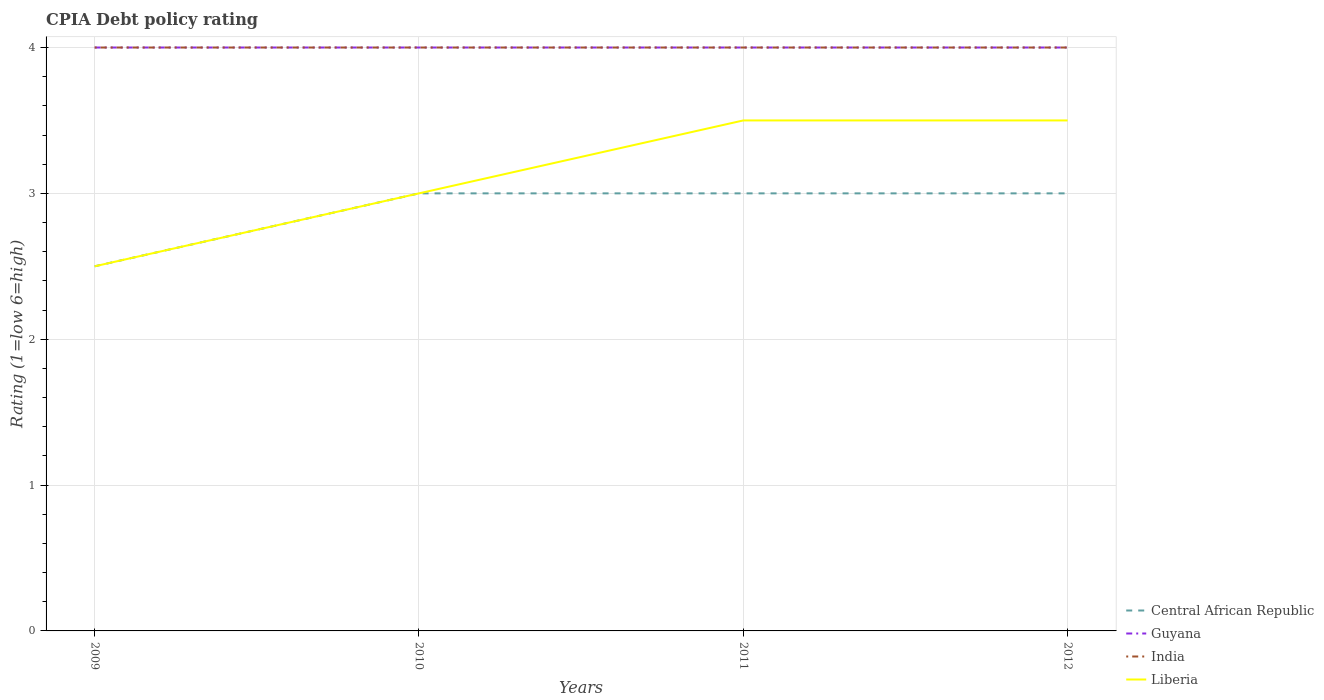How many different coloured lines are there?
Keep it short and to the point. 4. What is the total CPIA rating in India in the graph?
Your answer should be very brief. 0. What is the difference between the highest and the lowest CPIA rating in India?
Ensure brevity in your answer.  0. Is the CPIA rating in Guyana strictly greater than the CPIA rating in Central African Republic over the years?
Keep it short and to the point. No. Are the values on the major ticks of Y-axis written in scientific E-notation?
Keep it short and to the point. No. Does the graph contain any zero values?
Offer a terse response. No. Where does the legend appear in the graph?
Give a very brief answer. Bottom right. What is the title of the graph?
Offer a terse response. CPIA Debt policy rating. What is the label or title of the Y-axis?
Provide a succinct answer. Rating (1=low 6=high). What is the Rating (1=low 6=high) in India in 2009?
Offer a very short reply. 4. What is the Rating (1=low 6=high) of Liberia in 2009?
Offer a terse response. 2.5. What is the Rating (1=low 6=high) in Liberia in 2010?
Your answer should be very brief. 3. What is the Rating (1=low 6=high) of Central African Republic in 2011?
Your answer should be compact. 3. What is the Rating (1=low 6=high) in India in 2011?
Provide a short and direct response. 4. What is the Rating (1=low 6=high) in Central African Republic in 2012?
Provide a succinct answer. 3. What is the Rating (1=low 6=high) of Guyana in 2012?
Provide a succinct answer. 4. What is the Rating (1=low 6=high) in India in 2012?
Make the answer very short. 4. Across all years, what is the maximum Rating (1=low 6=high) in Central African Republic?
Provide a succinct answer. 3. Across all years, what is the minimum Rating (1=low 6=high) of Guyana?
Give a very brief answer. 4. Across all years, what is the minimum Rating (1=low 6=high) in India?
Your answer should be compact. 4. Across all years, what is the minimum Rating (1=low 6=high) in Liberia?
Provide a succinct answer. 2.5. What is the difference between the Rating (1=low 6=high) of Central African Republic in 2009 and that in 2010?
Offer a terse response. -0.5. What is the difference between the Rating (1=low 6=high) in Liberia in 2009 and that in 2010?
Keep it short and to the point. -0.5. What is the difference between the Rating (1=low 6=high) in India in 2009 and that in 2011?
Make the answer very short. 0. What is the difference between the Rating (1=low 6=high) in Liberia in 2009 and that in 2011?
Give a very brief answer. -1. What is the difference between the Rating (1=low 6=high) of India in 2009 and that in 2012?
Offer a very short reply. 0. What is the difference between the Rating (1=low 6=high) of India in 2010 and that in 2011?
Keep it short and to the point. 0. What is the difference between the Rating (1=low 6=high) in India in 2010 and that in 2012?
Provide a short and direct response. 0. What is the difference between the Rating (1=low 6=high) in Guyana in 2011 and that in 2012?
Provide a succinct answer. 0. What is the difference between the Rating (1=low 6=high) of Liberia in 2011 and that in 2012?
Keep it short and to the point. 0. What is the difference between the Rating (1=low 6=high) in Central African Republic in 2009 and the Rating (1=low 6=high) in Guyana in 2010?
Keep it short and to the point. -1.5. What is the difference between the Rating (1=low 6=high) of Central African Republic in 2009 and the Rating (1=low 6=high) of Liberia in 2010?
Your answer should be compact. -0.5. What is the difference between the Rating (1=low 6=high) in Guyana in 2009 and the Rating (1=low 6=high) in India in 2010?
Ensure brevity in your answer.  0. What is the difference between the Rating (1=low 6=high) of Central African Republic in 2009 and the Rating (1=low 6=high) of Guyana in 2011?
Give a very brief answer. -1.5. What is the difference between the Rating (1=low 6=high) in Guyana in 2009 and the Rating (1=low 6=high) in India in 2011?
Your response must be concise. 0. What is the difference between the Rating (1=low 6=high) of Central African Republic in 2009 and the Rating (1=low 6=high) of Guyana in 2012?
Provide a short and direct response. -1.5. What is the difference between the Rating (1=low 6=high) in Central African Republic in 2009 and the Rating (1=low 6=high) in Liberia in 2012?
Provide a succinct answer. -1. What is the difference between the Rating (1=low 6=high) in India in 2009 and the Rating (1=low 6=high) in Liberia in 2012?
Ensure brevity in your answer.  0.5. What is the difference between the Rating (1=low 6=high) in Central African Republic in 2010 and the Rating (1=low 6=high) in India in 2011?
Offer a very short reply. -1. What is the difference between the Rating (1=low 6=high) of Central African Republic in 2010 and the Rating (1=low 6=high) of Liberia in 2011?
Your answer should be compact. -0.5. What is the difference between the Rating (1=low 6=high) in Guyana in 2010 and the Rating (1=low 6=high) in India in 2011?
Your answer should be very brief. 0. What is the difference between the Rating (1=low 6=high) in India in 2010 and the Rating (1=low 6=high) in Liberia in 2011?
Keep it short and to the point. 0.5. What is the difference between the Rating (1=low 6=high) in Central African Republic in 2010 and the Rating (1=low 6=high) in Guyana in 2012?
Your answer should be compact. -1. What is the difference between the Rating (1=low 6=high) in Central African Republic in 2010 and the Rating (1=low 6=high) in India in 2012?
Offer a very short reply. -1. What is the difference between the Rating (1=low 6=high) of Guyana in 2010 and the Rating (1=low 6=high) of India in 2012?
Ensure brevity in your answer.  0. What is the difference between the Rating (1=low 6=high) of India in 2010 and the Rating (1=low 6=high) of Liberia in 2012?
Your answer should be compact. 0.5. What is the difference between the Rating (1=low 6=high) of Central African Republic in 2011 and the Rating (1=low 6=high) of Guyana in 2012?
Your response must be concise. -1. What is the difference between the Rating (1=low 6=high) in Central African Republic in 2011 and the Rating (1=low 6=high) in Liberia in 2012?
Your response must be concise. -0.5. What is the difference between the Rating (1=low 6=high) of Guyana in 2011 and the Rating (1=low 6=high) of India in 2012?
Offer a terse response. 0. What is the difference between the Rating (1=low 6=high) in Guyana in 2011 and the Rating (1=low 6=high) in Liberia in 2012?
Keep it short and to the point. 0.5. What is the difference between the Rating (1=low 6=high) of India in 2011 and the Rating (1=low 6=high) of Liberia in 2012?
Give a very brief answer. 0.5. What is the average Rating (1=low 6=high) of Central African Republic per year?
Your answer should be compact. 2.88. What is the average Rating (1=low 6=high) in Guyana per year?
Provide a short and direct response. 4. What is the average Rating (1=low 6=high) of India per year?
Your answer should be compact. 4. What is the average Rating (1=low 6=high) of Liberia per year?
Your answer should be compact. 3.12. In the year 2009, what is the difference between the Rating (1=low 6=high) of Central African Republic and Rating (1=low 6=high) of India?
Provide a succinct answer. -1.5. In the year 2009, what is the difference between the Rating (1=low 6=high) of Central African Republic and Rating (1=low 6=high) of Liberia?
Give a very brief answer. 0. In the year 2009, what is the difference between the Rating (1=low 6=high) of Guyana and Rating (1=low 6=high) of India?
Your answer should be very brief. 0. In the year 2009, what is the difference between the Rating (1=low 6=high) in Guyana and Rating (1=low 6=high) in Liberia?
Ensure brevity in your answer.  1.5. In the year 2010, what is the difference between the Rating (1=low 6=high) of Central African Republic and Rating (1=low 6=high) of Guyana?
Offer a terse response. -1. In the year 2010, what is the difference between the Rating (1=low 6=high) in Guyana and Rating (1=low 6=high) in India?
Provide a short and direct response. 0. In the year 2010, what is the difference between the Rating (1=low 6=high) in India and Rating (1=low 6=high) in Liberia?
Keep it short and to the point. 1. In the year 2011, what is the difference between the Rating (1=low 6=high) of Central African Republic and Rating (1=low 6=high) of India?
Offer a very short reply. -1. In the year 2011, what is the difference between the Rating (1=low 6=high) in Central African Republic and Rating (1=low 6=high) in Liberia?
Ensure brevity in your answer.  -0.5. In the year 2011, what is the difference between the Rating (1=low 6=high) in Guyana and Rating (1=low 6=high) in Liberia?
Give a very brief answer. 0.5. In the year 2012, what is the difference between the Rating (1=low 6=high) in Central African Republic and Rating (1=low 6=high) in Guyana?
Your answer should be very brief. -1. What is the ratio of the Rating (1=low 6=high) in Liberia in 2009 to that in 2010?
Offer a terse response. 0.83. What is the ratio of the Rating (1=low 6=high) in India in 2009 to that in 2011?
Your answer should be compact. 1. What is the ratio of the Rating (1=low 6=high) of Central African Republic in 2009 to that in 2012?
Give a very brief answer. 0.83. What is the ratio of the Rating (1=low 6=high) of India in 2009 to that in 2012?
Your answer should be compact. 1. What is the ratio of the Rating (1=low 6=high) of Liberia in 2009 to that in 2012?
Provide a short and direct response. 0.71. What is the ratio of the Rating (1=low 6=high) in Liberia in 2010 to that in 2011?
Your answer should be very brief. 0.86. What is the ratio of the Rating (1=low 6=high) in Central African Republic in 2010 to that in 2012?
Ensure brevity in your answer.  1. What is the ratio of the Rating (1=low 6=high) of Guyana in 2010 to that in 2012?
Provide a succinct answer. 1. What is the ratio of the Rating (1=low 6=high) of India in 2010 to that in 2012?
Your response must be concise. 1. What is the ratio of the Rating (1=low 6=high) of Central African Republic in 2011 to that in 2012?
Provide a short and direct response. 1. What is the ratio of the Rating (1=low 6=high) in Guyana in 2011 to that in 2012?
Give a very brief answer. 1. What is the difference between the highest and the second highest Rating (1=low 6=high) in Central African Republic?
Your answer should be compact. 0. What is the difference between the highest and the second highest Rating (1=low 6=high) in Liberia?
Make the answer very short. 0. What is the difference between the highest and the lowest Rating (1=low 6=high) of Liberia?
Make the answer very short. 1. 